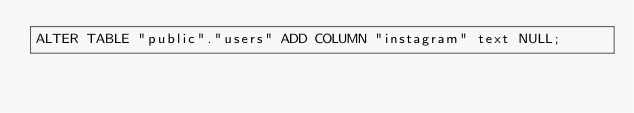<code> <loc_0><loc_0><loc_500><loc_500><_SQL_>ALTER TABLE "public"."users" ADD COLUMN "instagram" text NULL;
</code> 